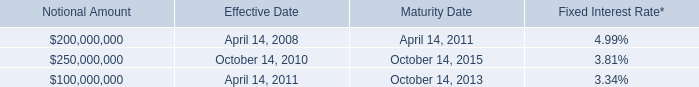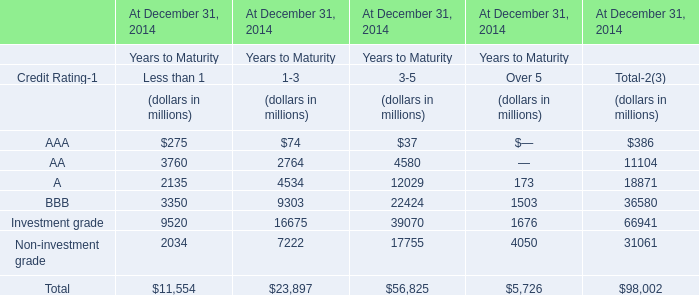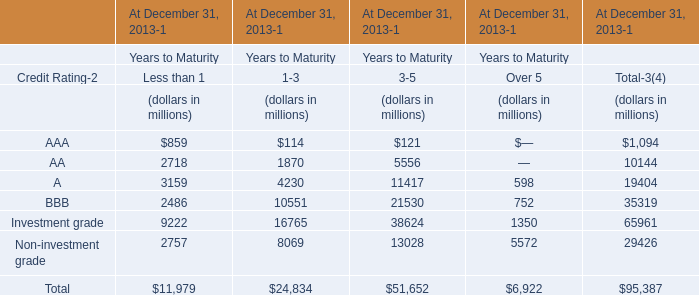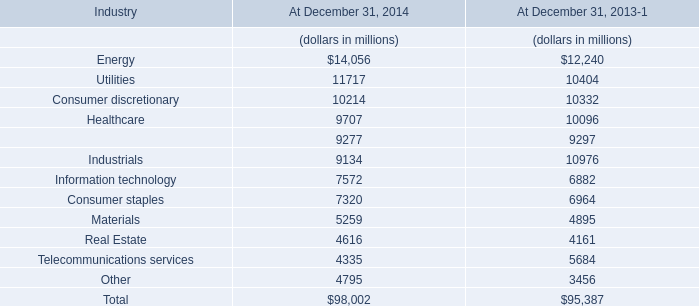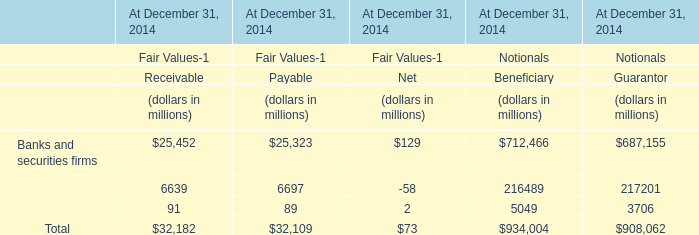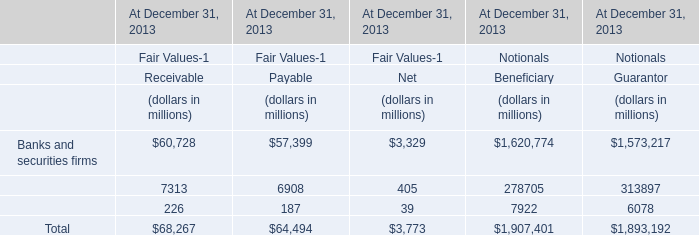In the section with lowest amount of BBB, what's the increasing rate of Investment grade ? 
Computations: ((7222 - 2034) / 2034)
Answer: 2.55064. 